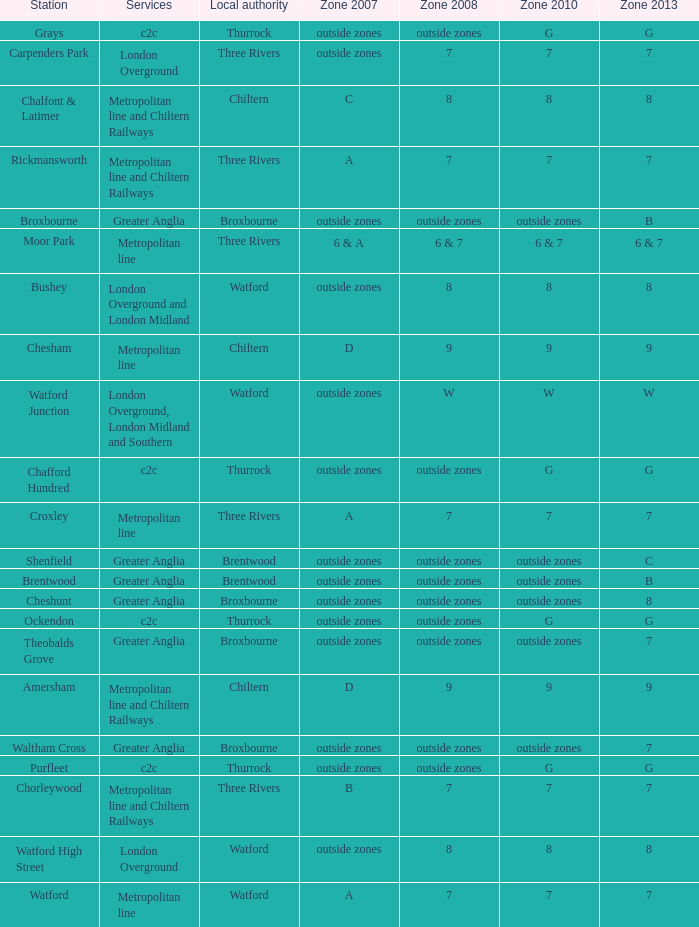Which Station has a Zone 2008 of 8, and a Zone 2007 of outside zones, and Services of london overground? Watford High Street. 